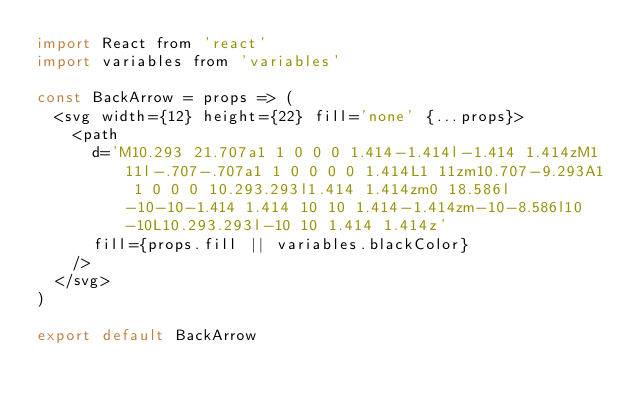<code> <loc_0><loc_0><loc_500><loc_500><_JavaScript_>import React from 'react'
import variables from 'variables'

const BackArrow = props => (
  <svg width={12} height={22} fill='none' {...props}>
    <path
      d='M10.293 21.707a1 1 0 0 0 1.414-1.414l-1.414 1.414zM1 11l-.707-.707a1 1 0 0 0 0 1.414L1 11zm10.707-9.293A1 1 0 0 0 10.293.293l1.414 1.414zm0 18.586l-10-10-1.414 1.414 10 10 1.414-1.414zm-10-8.586l10-10L10.293.293l-10 10 1.414 1.414z'
      fill={props.fill || variables.blackColor}
    />
  </svg>
)

export default BackArrow
</code> 